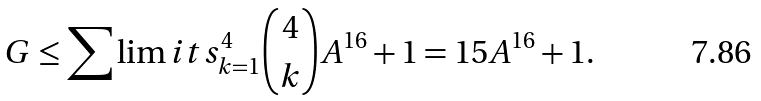Convert formula to latex. <formula><loc_0><loc_0><loc_500><loc_500>G \leq \sum \lim i t s _ { k = 1 } ^ { 4 } { 4 \choose k } A ^ { 1 6 } + 1 = 1 5 A ^ { 1 6 } + 1 .</formula> 